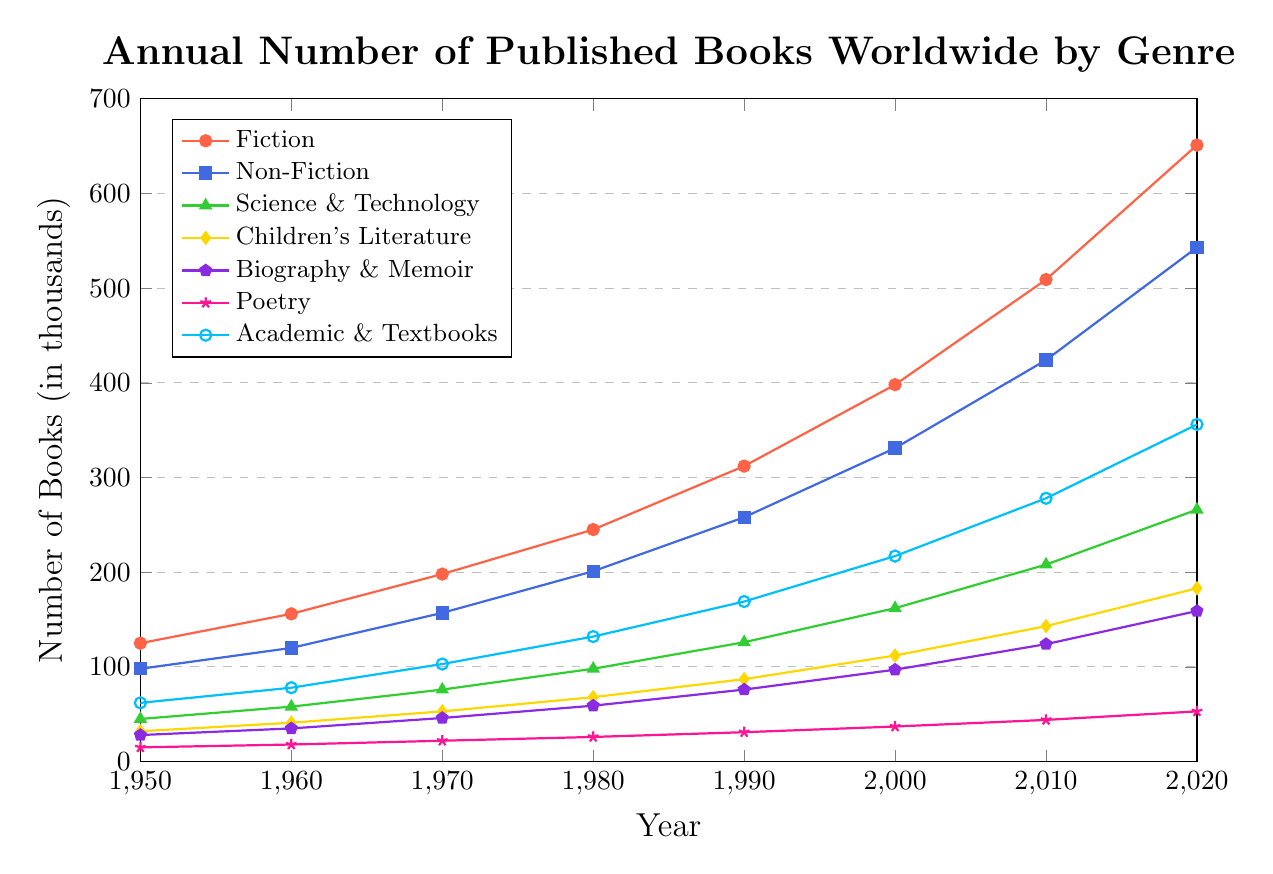Which genre has the highest number of published books in 2020? Look for the highest point on the chart for the year 2020. The "Fiction" line has the highest value.
Answer: Fiction How many more books were published in the Fiction genre in 1980 compared to the Science & Technology genre in 1980? Find the values for Fiction and Science & Technology in 1980: Fiction (245,000) and Science & Technology (98,000). Subtract the Science & Technology value from the Fiction value: 245,000 - 98,000 = 147,000.
Answer: 147,000 Which genre shows the least growth from 1950 to 2020? Calculate the difference between 1950 and 2020 for each genre and find the smallest: Poetry (53,000 - 15,000 = 38,000), which is the smallest among the genres.
Answer: Poetry In which decade did the number of published Children's Literature books surpass 100,000 for the first time? Inspect the values for Children's Literature across the decades. It first surpasses 100,000 in the year 2000.
Answer: 2000 What is the average number of published books in the Non-Fiction genre between 1950 and 2020? Add the values for Non-Fiction from 1950 to 2020 and divide by the number of decades: (98,000 + 120,000 + 157,000 + 201,000 + 258,000 + 331,000 + 424,000 + 543,000) / 8 = 266,500.
Answer: 266,500 How many books were published in total in the year 2020 across all genres shown? Sum the values from 2020 for all genres: 651,000 (Fiction) + 543,000 (Non-Fiction) + 266,000 (Science & Technology) + 183,000 (Children's Literature) + 159,000 (Biography & Memoir) + 53,000 (Poetry) + 356,000 (Academic & Textbooks) = 2,211,000.
Answer: 2,211,000 Which genre had the steepest increase in the number of published books between 2000 and 2020? Calculate the increase for each genre between 2000 and 2020 and identify the largest: Fiction (651,000 - 398,000 = 253,000) has the steepest increase.
Answer: Fiction Between which two decades did the number of published Academic & Textbooks books increase the most? Calculate the difference for each decade transition and find the greatest: 1950-1960 (16,000), 1960-1970 (25,000), 1970-1980 (29,000), 1980-1990 (37,000), 1990-2000 (48,000), 2000-2010 (61,000), 2010-2020 (78,000). The greatest increase is between 2010 and 2020.
Answer: 2010-2020 Compare the number of published Biography & Memoir books in 1950 and 2020. Is the number more than five times greater in 2020 than in 1950? Divide the 2020 value by the 1950 value and check if it is greater than 5: 159,000 / 28,000 ≈ 5.68, which is more than 5.
Answer: Yes What was the overall trend in the number of published books in the Poetry genre from 1950 to 2020? Observe the values for Poetry from 1950 to 2020. The trend shows a consistent but moderate increase over the decades.
Answer: Moderate increase 